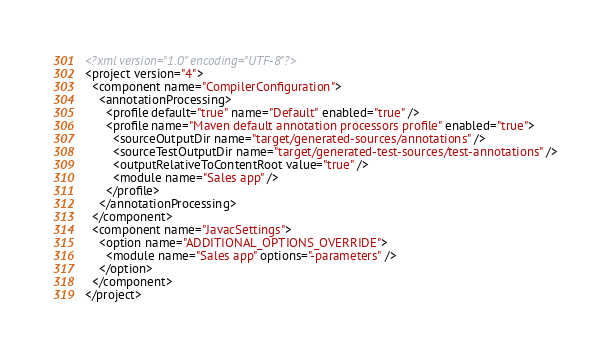Convert code to text. <code><loc_0><loc_0><loc_500><loc_500><_XML_><?xml version="1.0" encoding="UTF-8"?>
<project version="4">
  <component name="CompilerConfiguration">
    <annotationProcessing>
      <profile default="true" name="Default" enabled="true" />
      <profile name="Maven default annotation processors profile" enabled="true">
        <sourceOutputDir name="target/generated-sources/annotations" />
        <sourceTestOutputDir name="target/generated-test-sources/test-annotations" />
        <outputRelativeToContentRoot value="true" />
        <module name="Sales app" />
      </profile>
    </annotationProcessing>
  </component>
  <component name="JavacSettings">
    <option name="ADDITIONAL_OPTIONS_OVERRIDE">
      <module name="Sales app" options="-parameters" />
    </option>
  </component>
</project></code> 